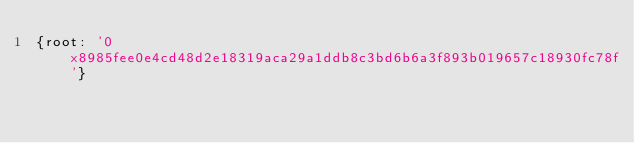Convert code to text. <code><loc_0><loc_0><loc_500><loc_500><_YAML_>{root: '0x8985fee0e4cd48d2e18319aca29a1ddb8c3bd6b6a3f893b019657c18930fc78f'}
</code> 